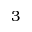<formula> <loc_0><loc_0><loc_500><loc_500>3</formula> 